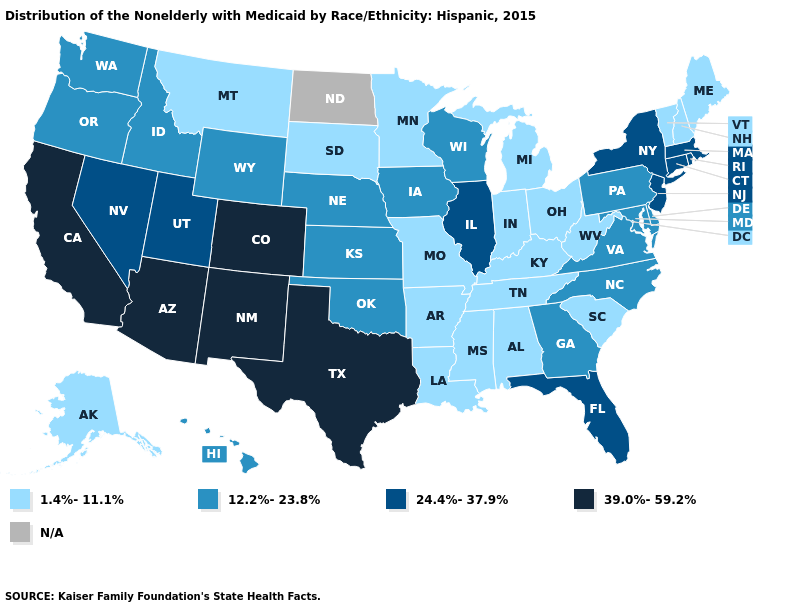Is the legend a continuous bar?
Answer briefly. No. Name the states that have a value in the range 24.4%-37.9%?
Quick response, please. Connecticut, Florida, Illinois, Massachusetts, Nevada, New Jersey, New York, Rhode Island, Utah. Name the states that have a value in the range 12.2%-23.8%?
Give a very brief answer. Delaware, Georgia, Hawaii, Idaho, Iowa, Kansas, Maryland, Nebraska, North Carolina, Oklahoma, Oregon, Pennsylvania, Virginia, Washington, Wisconsin, Wyoming. What is the value of West Virginia?
Give a very brief answer. 1.4%-11.1%. Does the first symbol in the legend represent the smallest category?
Keep it brief. Yes. What is the lowest value in the South?
Concise answer only. 1.4%-11.1%. Is the legend a continuous bar?
Keep it brief. No. What is the value of Maine?
Be succinct. 1.4%-11.1%. What is the lowest value in the MidWest?
Be succinct. 1.4%-11.1%. Does the map have missing data?
Write a very short answer. Yes. What is the highest value in the USA?
Give a very brief answer. 39.0%-59.2%. Among the states that border New York , which have the highest value?
Be succinct. Connecticut, Massachusetts, New Jersey. Name the states that have a value in the range N/A?
Answer briefly. North Dakota. 